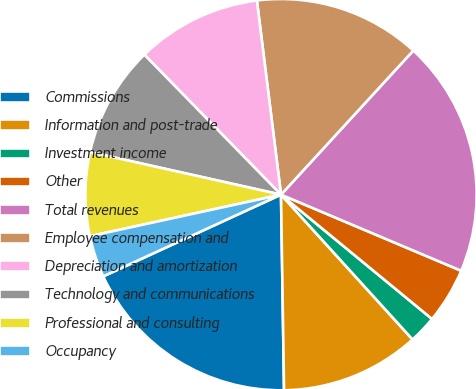<chart> <loc_0><loc_0><loc_500><loc_500><pie_chart><fcel>Commissions<fcel>Information and post-trade<fcel>Investment income<fcel>Other<fcel>Total revenues<fcel>Employee compensation and<fcel>Depreciation and amortization<fcel>Technology and communications<fcel>Professional and consulting<fcel>Occupancy<nl><fcel>18.39%<fcel>11.49%<fcel>2.3%<fcel>4.6%<fcel>19.54%<fcel>13.79%<fcel>10.34%<fcel>9.2%<fcel>6.9%<fcel>3.45%<nl></chart> 